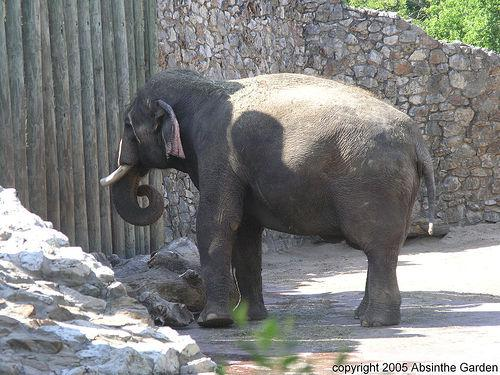Question: what is that?
Choices:
A. An elephant.
B. A tiger.
C. A hippo.
D. A giraffe.
Answer with the letter. Answer: A Question: how many legs does it have?
Choices:
A. Three.
B. Two.
C. Five.
D. Four.
Answer with the letter. Answer: D 